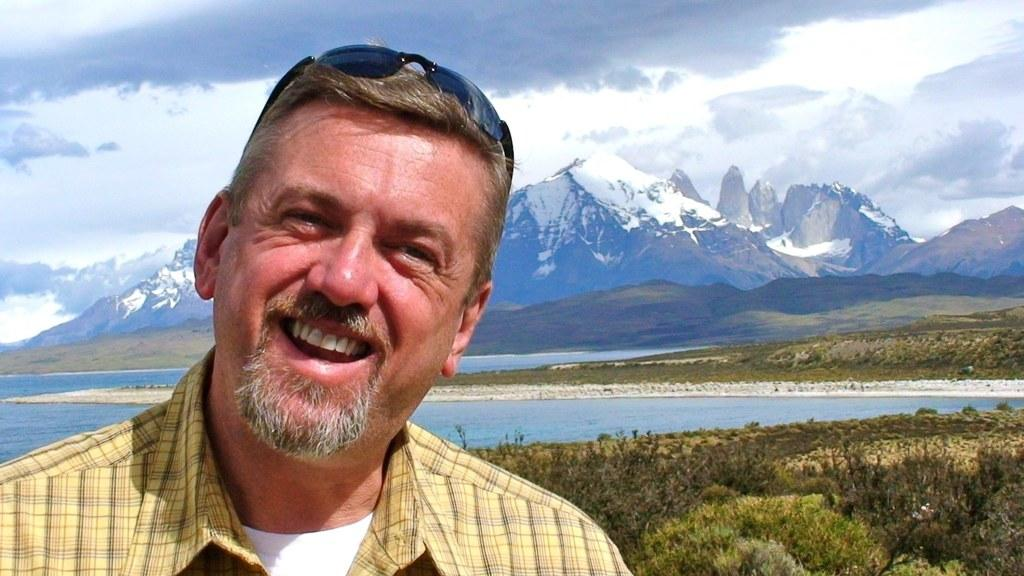What is the person in the image wearing? The person is wearing a yellow t-shirt. What is the person's facial expression in the image? The person is smiling. What accessory is on the person's head? The person has sunglasses on their head. What can be seen in the background of the image? There is a water body, hills, and plants in the background of the image. What is the condition of the sky in the image? The sky is cloudy. What type of seed is the person planting in the image? There is no seed or planting activity depicted in the image. What suggestion does the person have for the shop in the image? There is no shop or suggestion present in the image. 